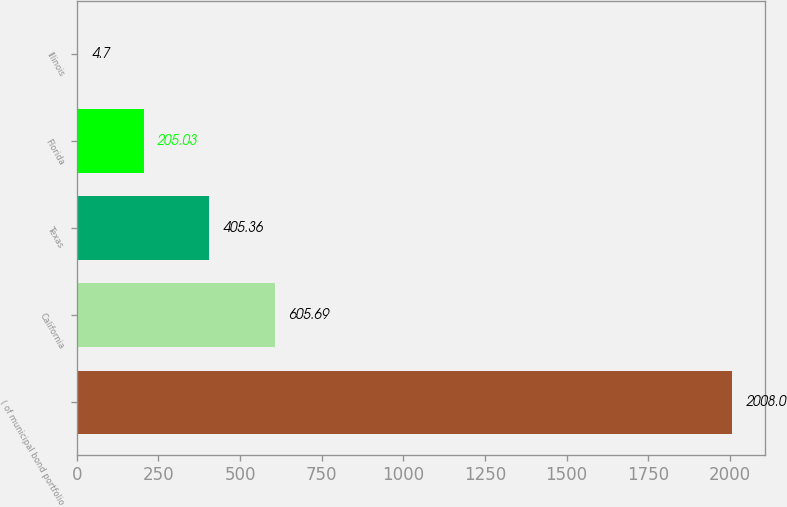<chart> <loc_0><loc_0><loc_500><loc_500><bar_chart><fcel>( of municipal bond portfolio<fcel>California<fcel>Texas<fcel>Florida<fcel>Illinois<nl><fcel>2008<fcel>605.69<fcel>405.36<fcel>205.03<fcel>4.7<nl></chart> 